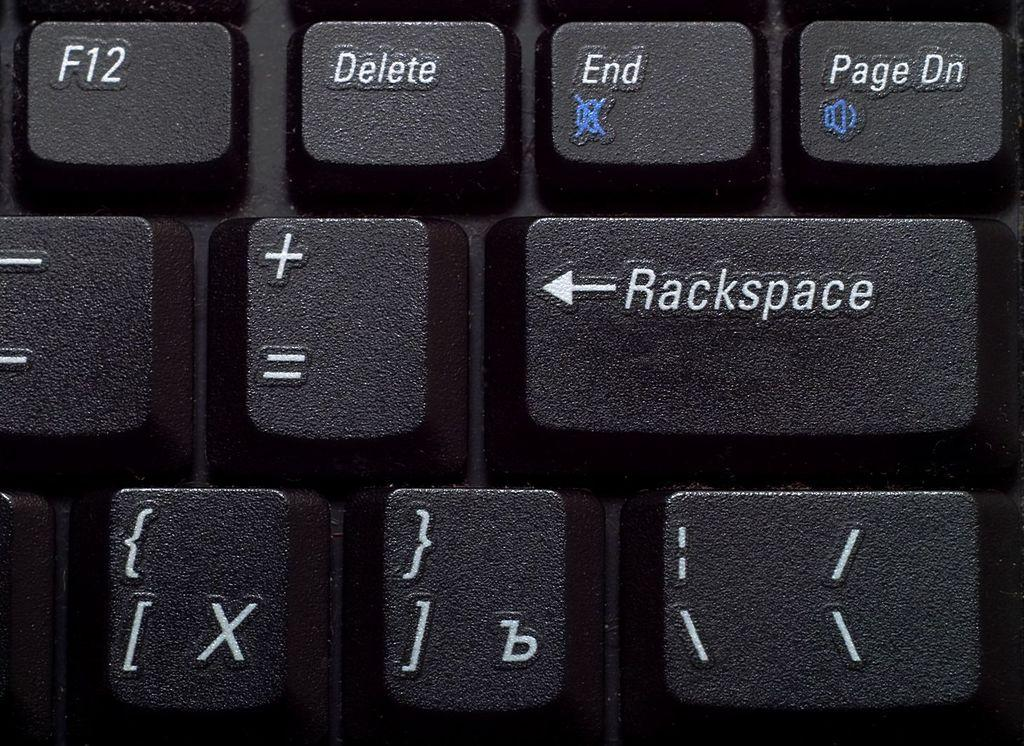<image>
Create a compact narrative representing the image presented. A closeup of a few keys on a keyboard, including F12, Delete, End, Page Dn and Backspace. 